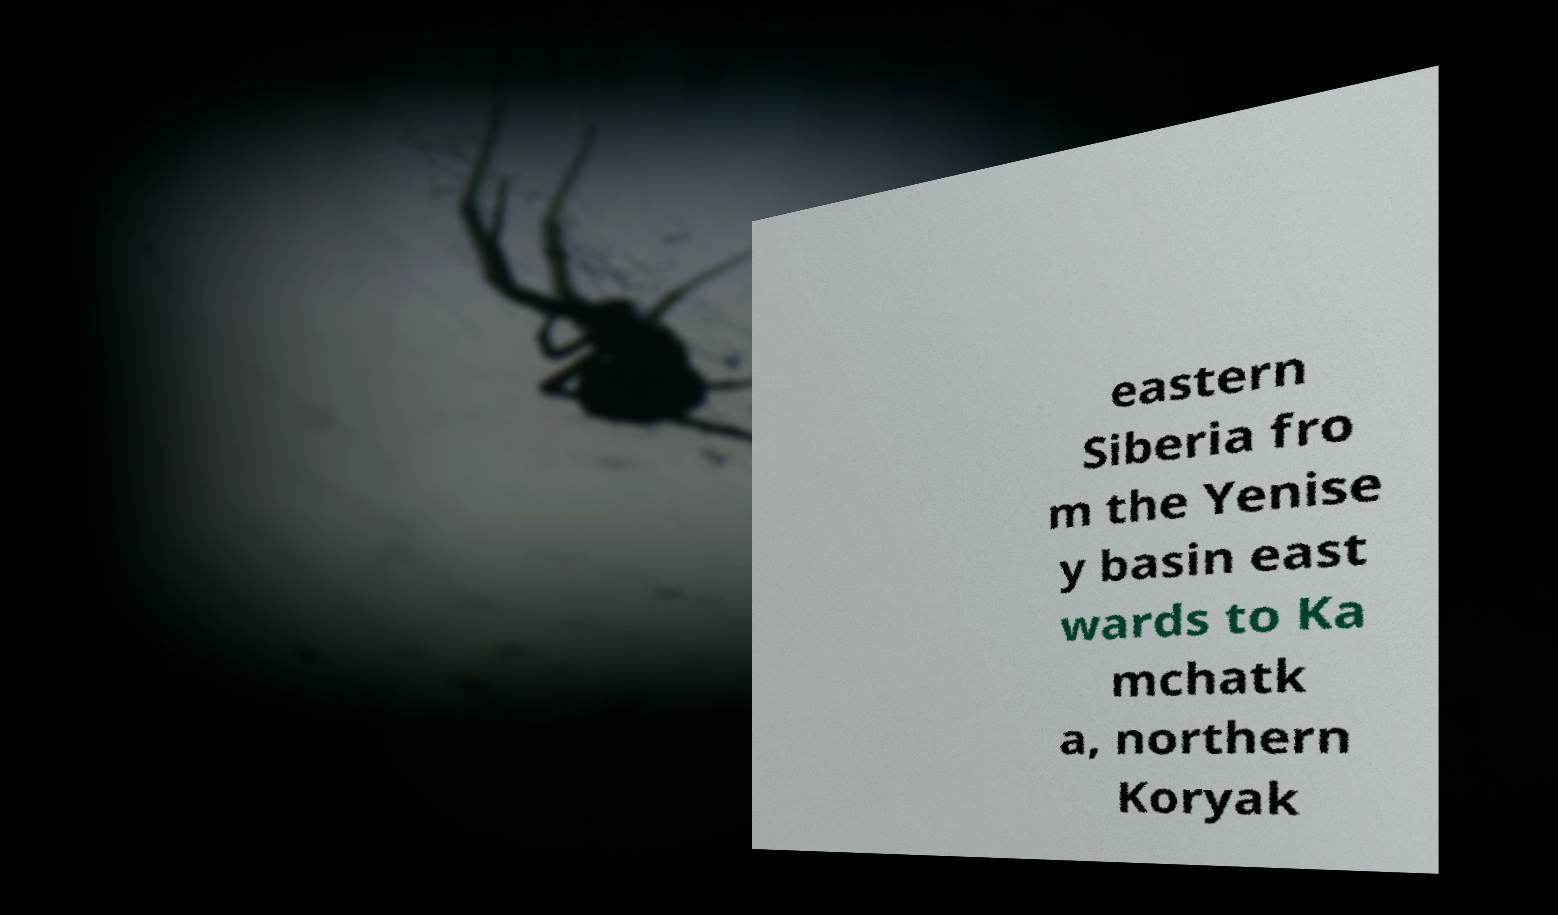Please identify and transcribe the text found in this image. eastern Siberia fro m the Yenise y basin east wards to Ka mchatk a, northern Koryak 